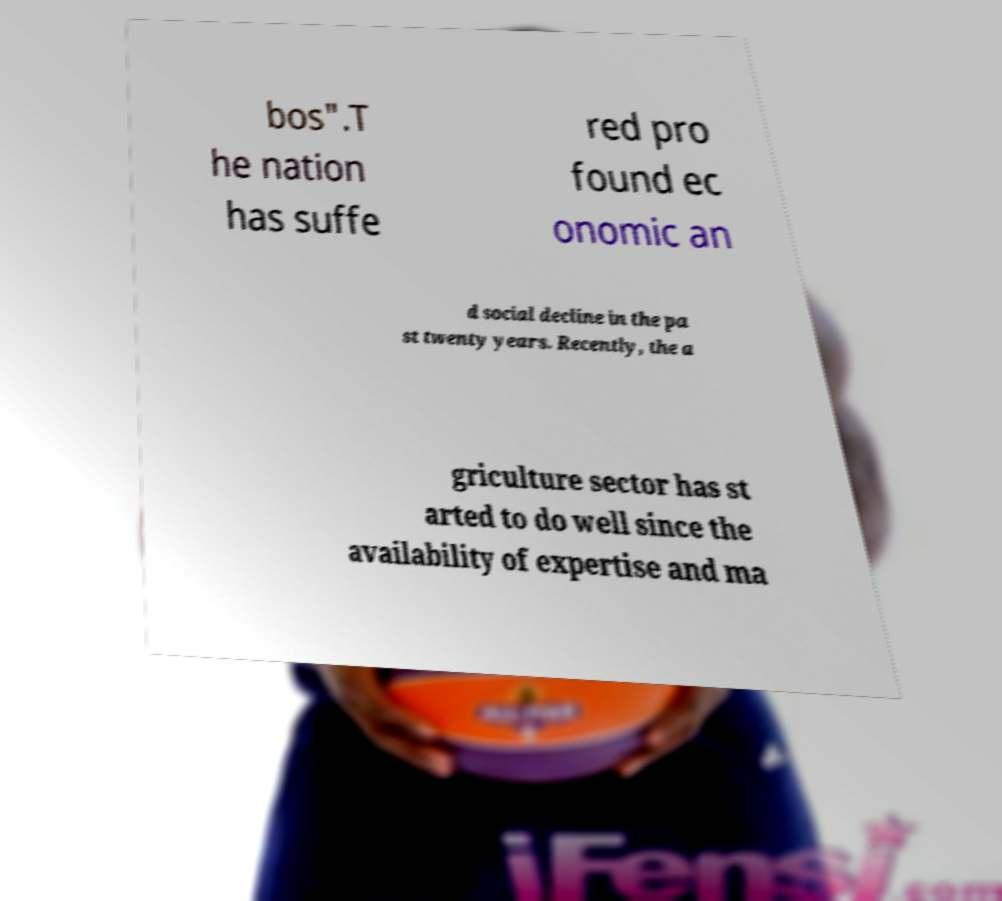Can you read and provide the text displayed in the image?This photo seems to have some interesting text. Can you extract and type it out for me? bos".T he nation has suffe red pro found ec onomic an d social decline in the pa st twenty years. Recently, the a griculture sector has st arted to do well since the availability of expertise and ma 